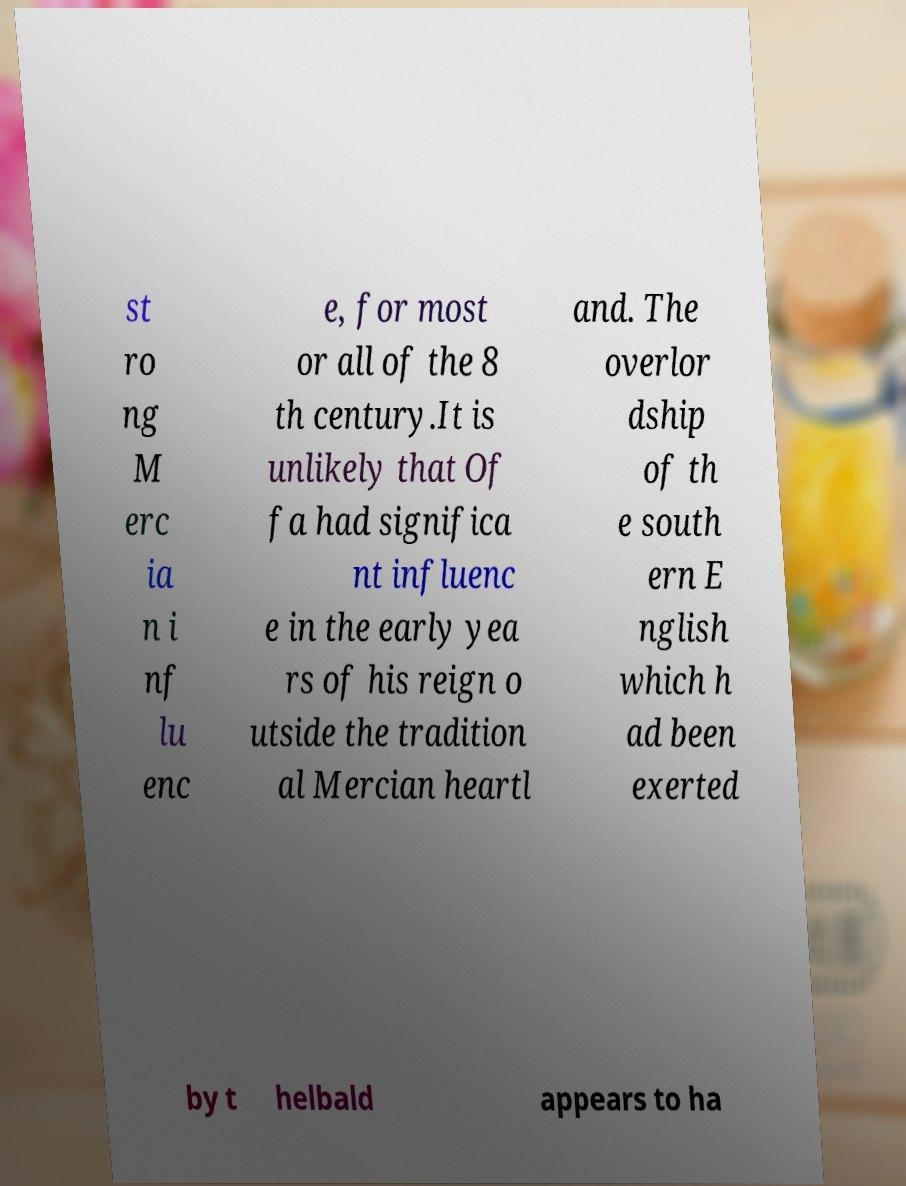Can you accurately transcribe the text from the provided image for me? st ro ng M erc ia n i nf lu enc e, for most or all of the 8 th century.It is unlikely that Of fa had significa nt influenc e in the early yea rs of his reign o utside the tradition al Mercian heartl and. The overlor dship of th e south ern E nglish which h ad been exerted by t helbald appears to ha 